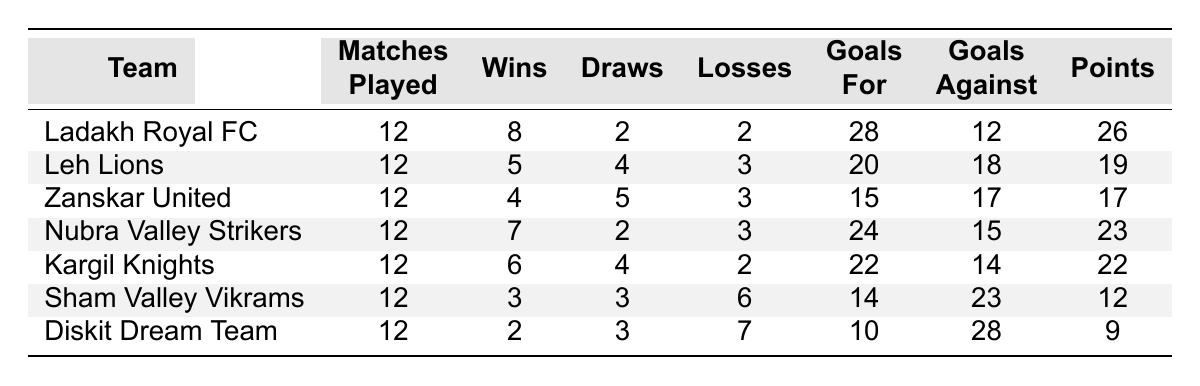What is the total number of matches played by all teams? To find the total number of matches played, we sum the "Matches Played" for each team: 12 + 12 + 12 + 12 + 12 + 12 + 12 = 84.
Answer: 84 Which team has the highest number of points? By examining the "Points" column, Ladakh Royal FC has the highest points with 26.
Answer: Ladakh Royal FC How many goals did Diskit Dream Team score in total? Diskit Dream Team's "Goals For" is shown as 10.
Answer: 10 Which team had the least amount of wins? The "Wins" for each team were compared, and Diskit Dream Team has the fewest wins with 2.
Answer: Diskit Dream Team What is the point difference between Kargil Knights and Leh Lions? Kargil Knights have 22 points, and Leh Lions have 19 points. The difference is 22 - 19 = 3.
Answer: 3 How many total goals were scored by the teams in this table? Summing the "Goals For" gives: 28 + 20 + 15 + 24 + 22 + 14 + 10 = 133.
Answer: 133 Is it true that Sham Valley Vikrams lost more matches than they won? Sham Valley Vikrams have 3 wins and 6 losses. Since 6 is greater than 3, the statement is true.
Answer: Yes Which team had a goal difference of +12 or greater? Calculating goal difference (Goals For - Goals Against) for each team, only Ladakh Royal FC (28 - 12 = +16) and Nubra Valley Strikers (24 - 15 = +9) qualify, but only Ladakh Royal FC meets the requirement.
Answer: Ladakh Royal FC What percentage of matches did Leh Lions win? Leh Lions won 5 out of 12 matches. To find the percentage: (5/12) * 100 = 41.67%.
Answer: 41.67% Which team had the highest number of draws? Checking the "Draws" column, Leh Lions had the highest number of draws with 4.
Answer: Leh Lions 